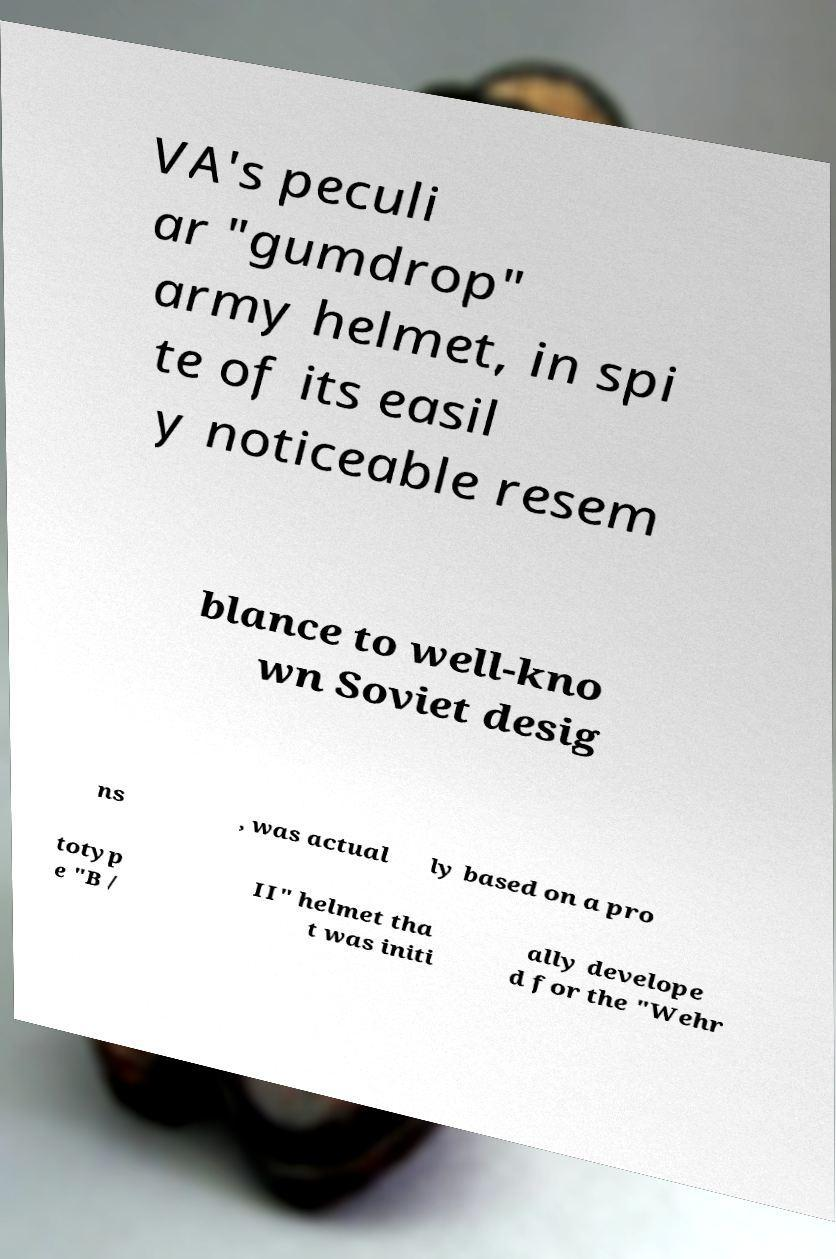Can you accurately transcribe the text from the provided image for me? VA's peculi ar "gumdrop" army helmet, in spi te of its easil y noticeable resem blance to well-kno wn Soviet desig ns , was actual ly based on a pro totyp e "B / II" helmet tha t was initi ally develope d for the "Wehr 